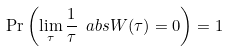Convert formula to latex. <formula><loc_0><loc_0><loc_500><loc_500>\Pr \left ( \lim _ { \tau } \frac { 1 } { \tau } \ a b s { W ( \tau ) } = 0 \right ) = 1</formula> 